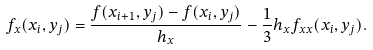Convert formula to latex. <formula><loc_0><loc_0><loc_500><loc_500>f _ { x } ( x _ { i } , y _ { j } ) = \frac { f ( x _ { i + 1 } , y _ { j } ) - f ( x _ { i } , y _ { j } ) } { h _ { x } } - \frac { 1 } { 3 } h _ { x } f _ { x x } ( x _ { i } , y _ { j } ) .</formula> 